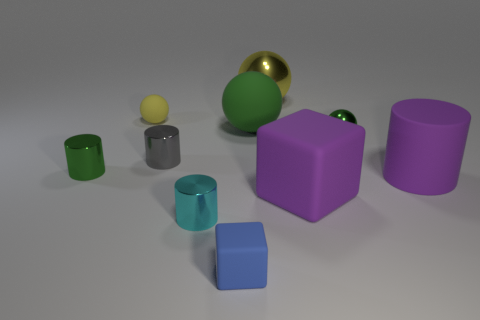What number of objects are either green objects that are in front of the small metal sphere or big red rubber objects?
Your answer should be compact. 1. The large sphere behind the big matte object that is behind the cylinder that is to the right of the small blue rubber block is what color?
Provide a succinct answer. Yellow. There is a cylinder that is made of the same material as the big purple cube; what is its color?
Your response must be concise. Purple. How many small green objects are made of the same material as the blue object?
Offer a very short reply. 0. There is a blue rubber cube that is right of the gray shiny cylinder; does it have the same size as the small cyan metallic cylinder?
Make the answer very short. Yes. There is a metallic ball that is the same size as the yellow rubber ball; what color is it?
Your answer should be very brief. Green. How many green shiny cylinders are on the left side of the purple rubber cylinder?
Offer a terse response. 1. Are there any big cylinders?
Keep it short and to the point. Yes. There is a green object on the left side of the small thing behind the small green metallic object that is behind the tiny gray metallic object; what is its size?
Make the answer very short. Small. What number of other objects are the same size as the gray shiny cylinder?
Your answer should be very brief. 5. 